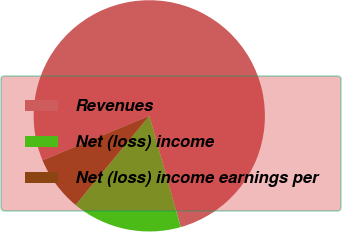Convert chart. <chart><loc_0><loc_0><loc_500><loc_500><pie_chart><fcel>Revenues<fcel>Net (loss) income<fcel>Net (loss) income earnings per<nl><fcel>76.89%<fcel>15.4%<fcel>7.71%<nl></chart> 